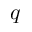Convert formula to latex. <formula><loc_0><loc_0><loc_500><loc_500>q</formula> 